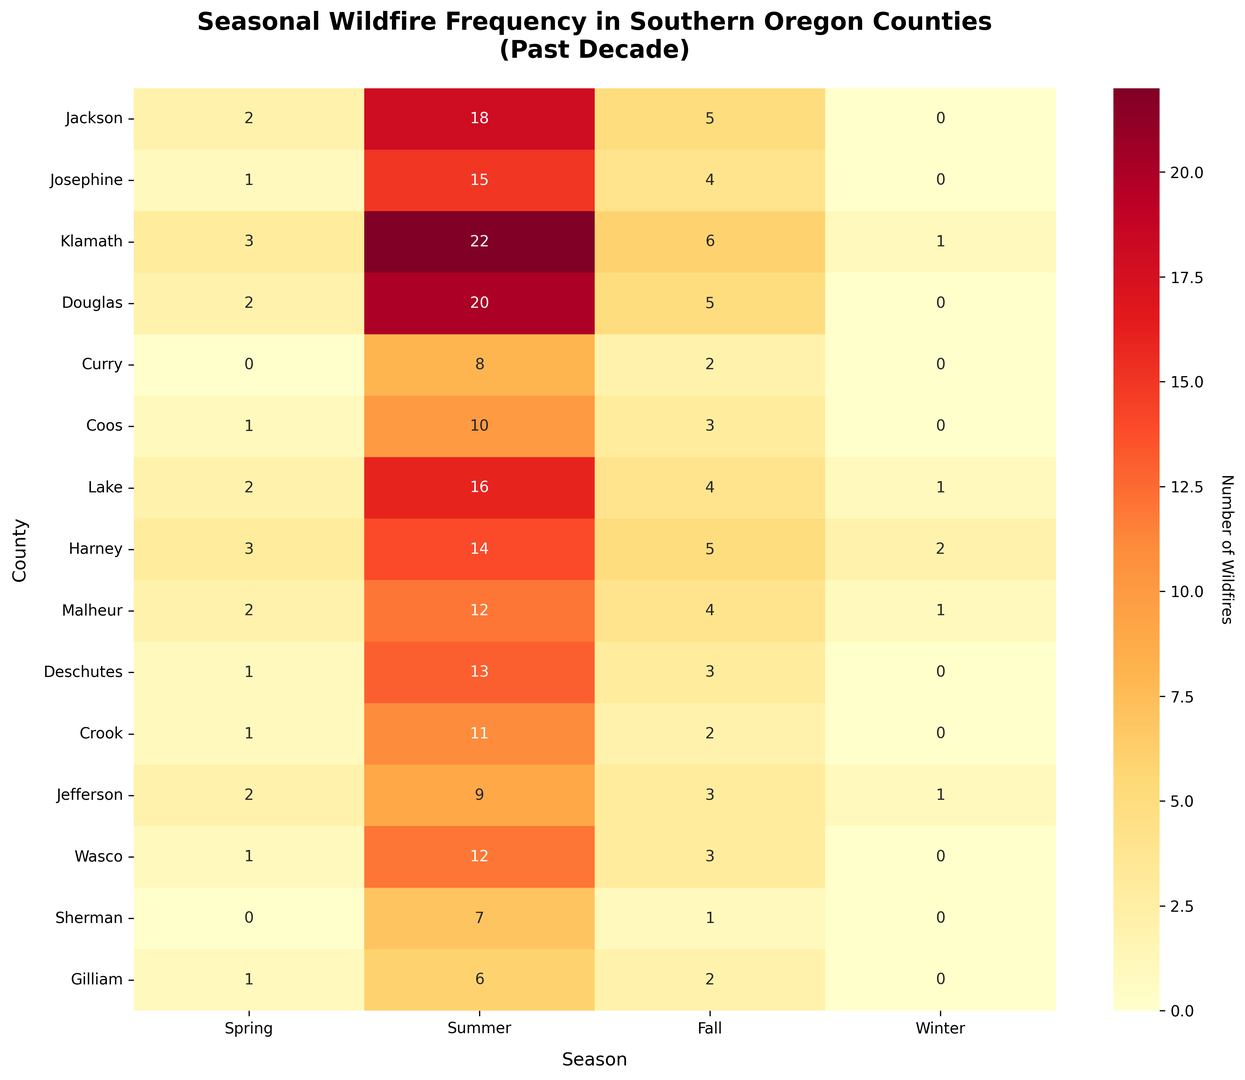What is the total number of wildfires in Jackson County throughout the year? Sum the values for each season in Jackson County: 2 (Spring) + 18 (Summer) + 5 (Fall) + 0 (Winter).
Answer: 25 Which county had the highest number of wildfires in the Summer? The county with the highest value in the Summer column is Klamath with 22 wildfires.
Answer: Klamath Comparing Jefferson and Lake counties, which had more wildfires in the Winter season? From the Winter season column, Jefferson had 1 wildfire while Lake had 1 wildfire. They both had the same number.
Answer: Same What is the average number of wildfires during Fall across all counties? To find the average, sum the values in the Fall column and divide by the number of counties: (5 + 4 + 6 + 5 + 2 + 3 + 4 + 5 + 4 + 3 + 2 + 3 + 3 + 1 + 2) / 15 = 52 / 15 ≈ 3.47
Answer: 3.47 Which season recorded the fewest wildfires overall across all counties? Sum the values for each season across all counties: (Spring: 22, Summer: 203, Fall: 52, Winter: 6). Winter recorded the fewest wildfires.
Answer: Winter Comparing Curry and Coos counties, in which season did they have the largest difference in wildfire frequency? Subtract the values for Curry and Coos for each season: Spring: 0-1 = -1, Summer: 8-10 = -2, Fall: 2-3 = -1, Winter: 0-0 = 0. The largest difference is in Summer, with a difference of 2.
Answer: Summer What is the median number of wildfires in Spring across all counties? List the Spring values in order: 0, 0, 1, 1, 1, 1, 2, 2, 2, 2, 2, 3, 3, 3. Since there is an even number of counties (15), the median is the average of the 7th and 8th values, both of which are 2.
Answer: 2 Which county has the lowest overall number of wildfires over the past decade? Sum the total wildfires for each county and find the minimum: Curry (10).
Answer: Curry In which counties did the number of wildfires during winter equal or exceed the number in spring? Check each county: Klamath, Harney, Malheur, and Jefferson all meet this criterion (1 ≥ 3, 2 ≥ 3, 1 ≥ 2, and 1 ≥ 2 respectively).
Answer: Klamath, Harney, Malheur, Jefferson How many counties have more than 10 wildfires in the Summer? Count counties with summer wildfires greater than 10: Jackson, Josephine, Klamath, Douglas, Coos, Lake, Harney, Malheur, Deschutes had 9 counties.
Answer: 9 